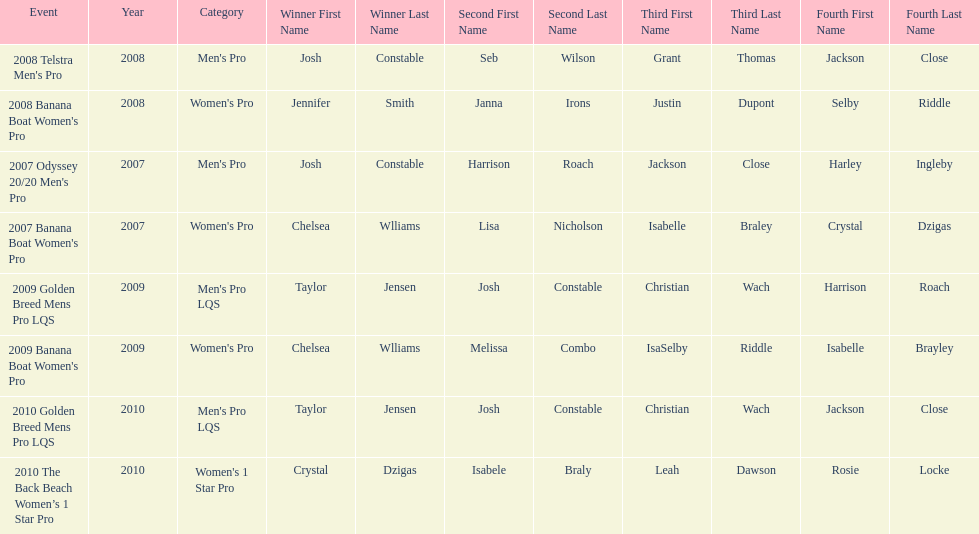How many times was josh constable the winner after 2007? 1. 